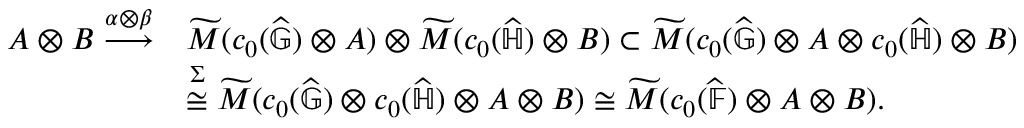<formula> <loc_0><loc_0><loc_500><loc_500>\begin{array} { r l } { A \otimes B \overset { \alpha \otimes \beta } { \longrightarrow } } & { \widetilde { M } ( c _ { 0 } ( \widehat { \mathbb { G } } ) \otimes A ) \otimes \widetilde { M } ( c _ { 0 } ( \widehat { \mathbb { H } } ) \otimes B ) \subset \widetilde { M } ( c _ { 0 } ( \widehat { \mathbb { G } } ) \otimes A \otimes c _ { 0 } ( \widehat { \mathbb { H } } ) \otimes B ) } \\ & { \overset { \Sigma } { \cong } \widetilde { M } ( c _ { 0 } ( \widehat { \mathbb { G } } ) \otimes c _ { 0 } ( \widehat { \mathbb { H } } ) \otimes A \otimes B ) \cong \widetilde { M } ( c _ { 0 } ( \widehat { \mathbb { F } } ) \otimes A \otimes B ) . } \end{array}</formula> 